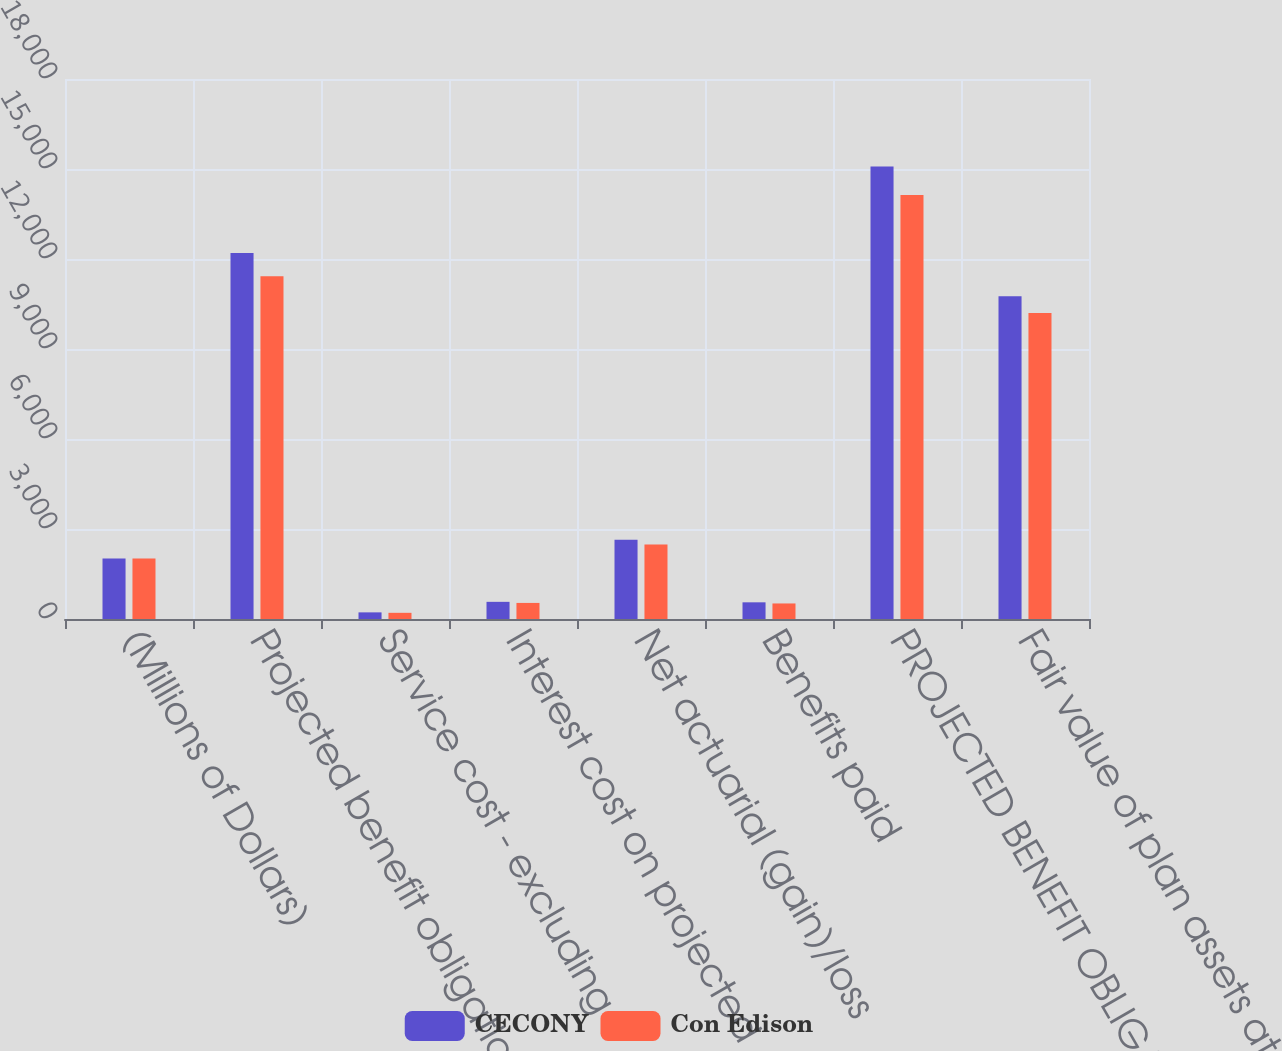Convert chart to OTSL. <chart><loc_0><loc_0><loc_500><loc_500><stacked_bar_chart><ecel><fcel>(Millions of Dollars)<fcel>Projected benefit obligation<fcel>Service cost - excluding<fcel>Interest cost on projected<fcel>Net actuarial (gain)/loss<fcel>Benefits paid<fcel>PROJECTED BENEFIT OBLIGATION<fcel>Fair value of plan assets at<nl><fcel>CECONY<fcel>2014<fcel>12197<fcel>221<fcel>572<fcel>2641<fcel>556<fcel>15081<fcel>10755<nl><fcel>Con Edison<fcel>2014<fcel>11429<fcel>206<fcel>536<fcel>2484<fcel>518<fcel>14137<fcel>10197<nl></chart> 